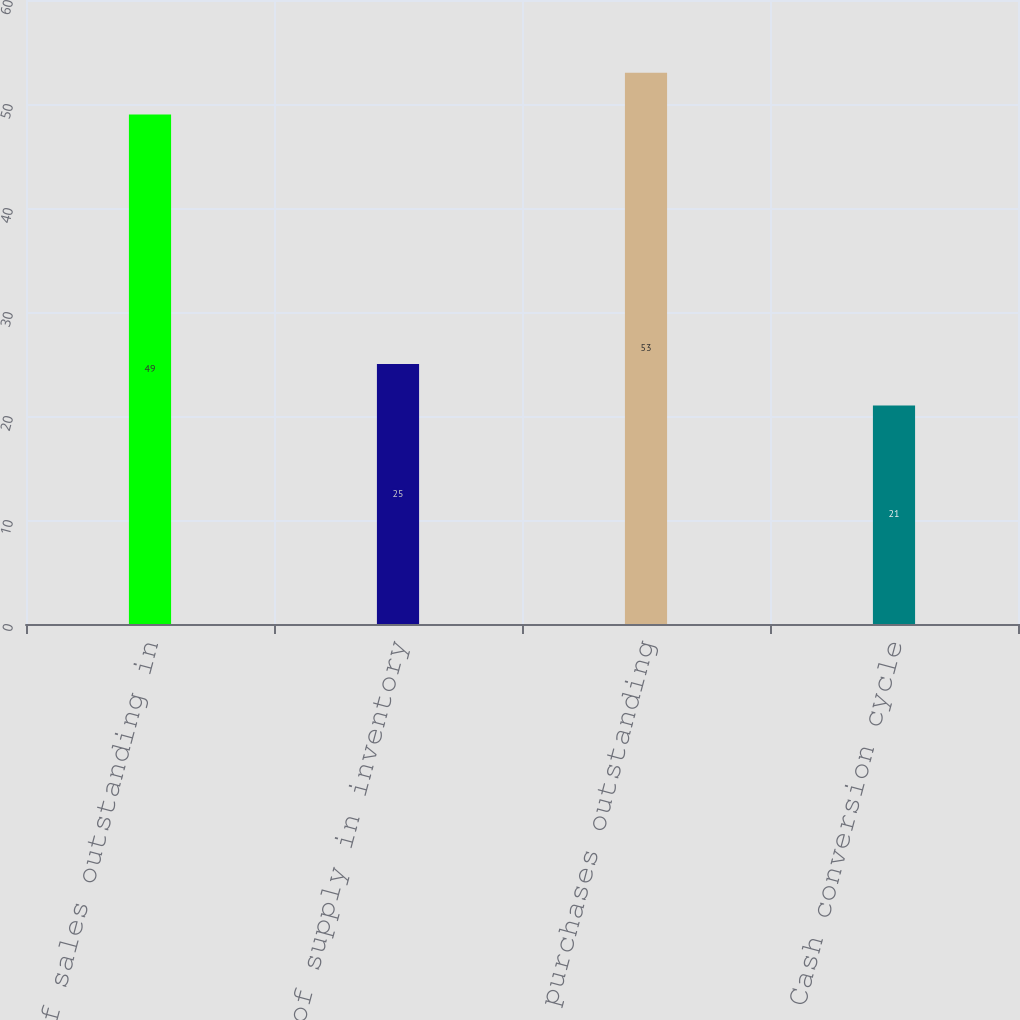Convert chart to OTSL. <chart><loc_0><loc_0><loc_500><loc_500><bar_chart><fcel>Days of sales outstanding in<fcel>Days of supply in inventory<fcel>Days of purchases outstanding<fcel>Cash conversion cycle<nl><fcel>49<fcel>25<fcel>53<fcel>21<nl></chart> 